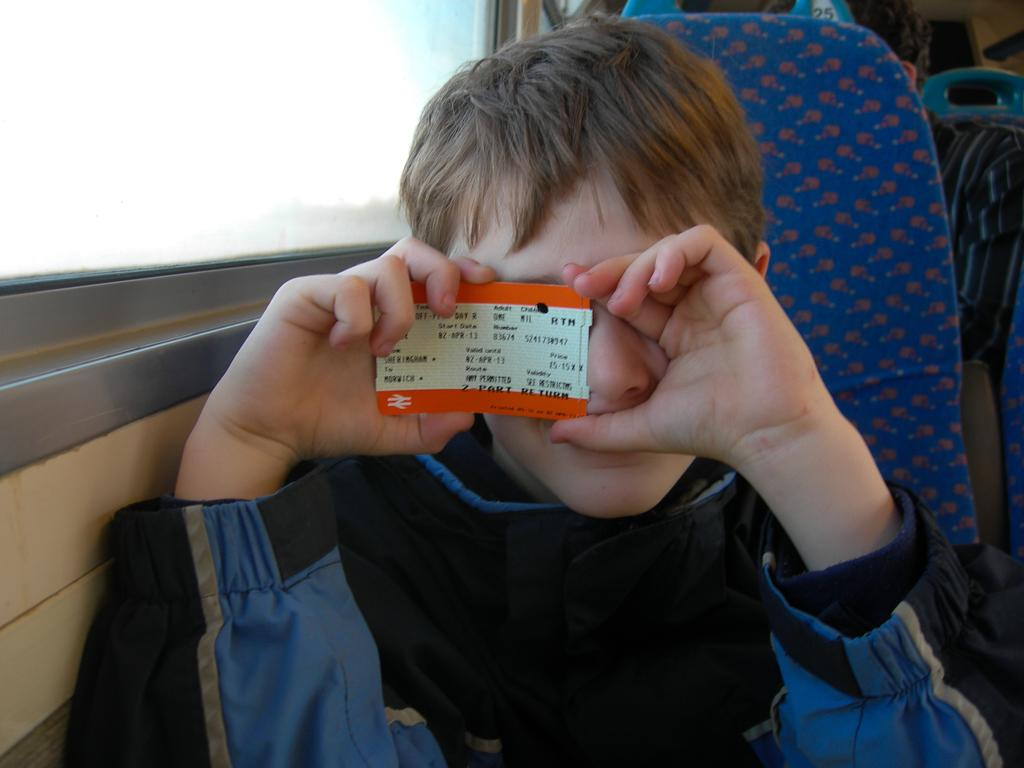Who is the main subject in the image? There is a boy in the image. What is the boy doing in the image? The boy is sitting on a seat. What is the boy holding in the image? The boy is holding a card. What can be seen on the left side of the boy? There is a window on the left side of the boy. Can you describe the position of the other person in the image? There is another person sitting behind the boy. What type of quilt is covering the bed in the image? There is no bed or quilt present in the image. How much dust can be seen on the floor in the image? There is no mention of dust or a floor in the image. 